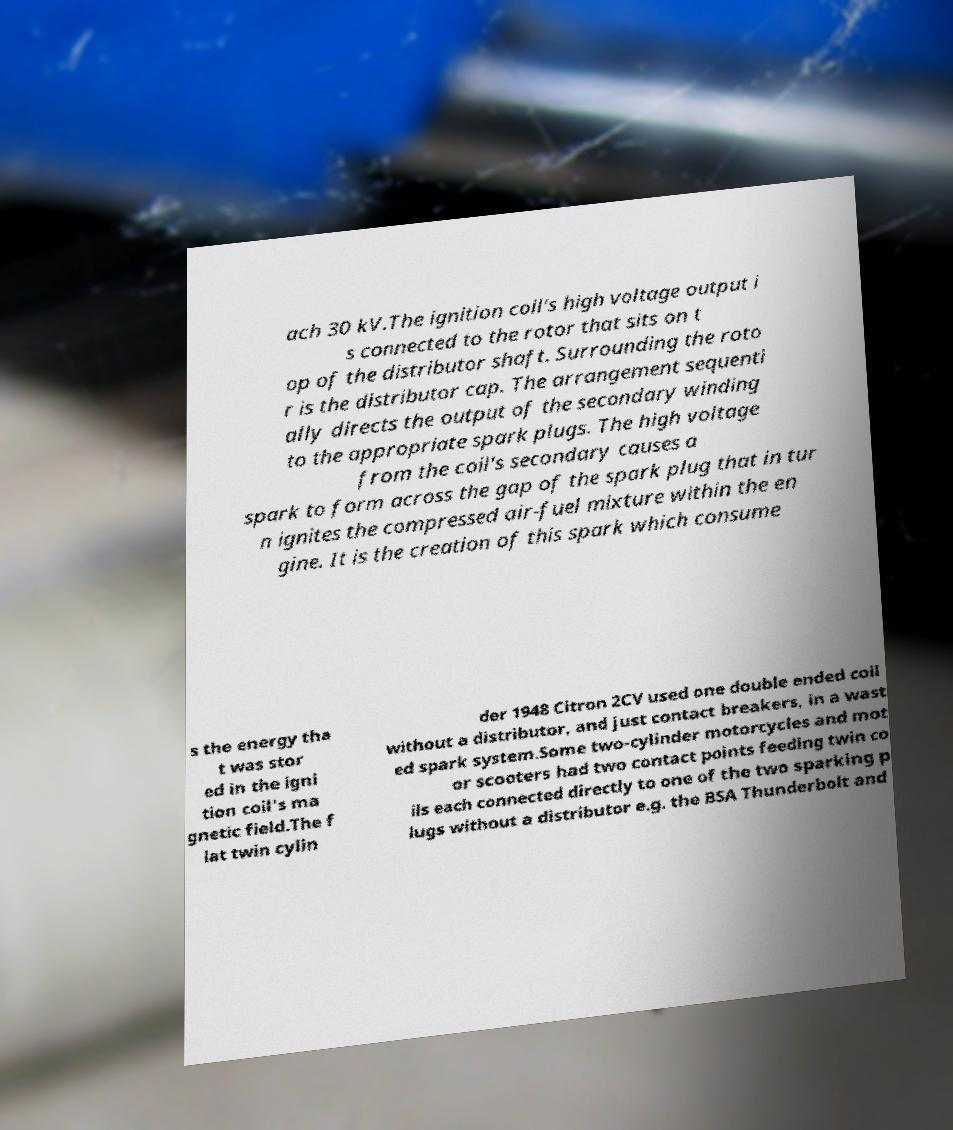There's text embedded in this image that I need extracted. Can you transcribe it verbatim? ach 30 kV.The ignition coil's high voltage output i s connected to the rotor that sits on t op of the distributor shaft. Surrounding the roto r is the distributor cap. The arrangement sequenti ally directs the output of the secondary winding to the appropriate spark plugs. The high voltage from the coil's secondary causes a spark to form across the gap of the spark plug that in tur n ignites the compressed air-fuel mixture within the en gine. It is the creation of this spark which consume s the energy tha t was stor ed in the igni tion coil's ma gnetic field.The f lat twin cylin der 1948 Citron 2CV used one double ended coil without a distributor, and just contact breakers, in a wast ed spark system.Some two-cylinder motorcycles and mot or scooters had two contact points feeding twin co ils each connected directly to one of the two sparking p lugs without a distributor e.g. the BSA Thunderbolt and 